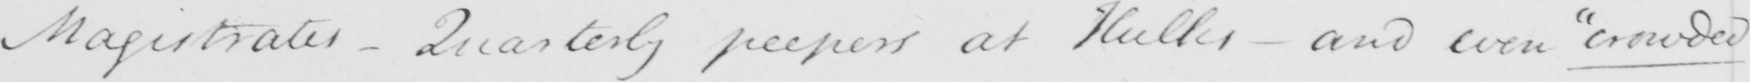Can you tell me what this handwritten text says? Magistrates - Quarterly peepers at Hulks - and even  " crowded " 